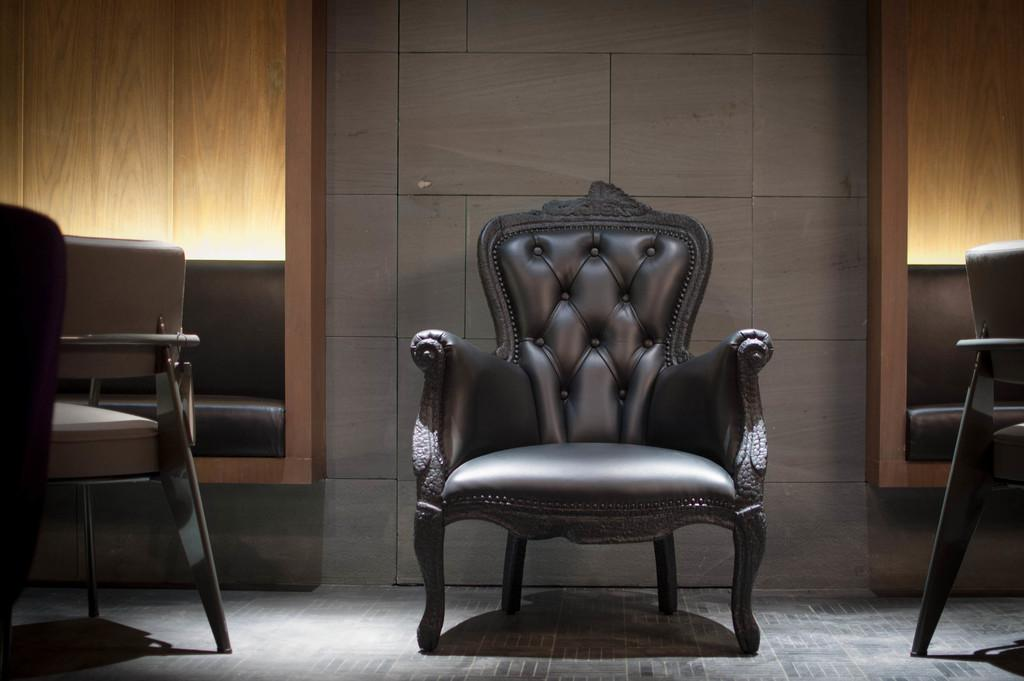What is the main object in the middle of the image? There is a black color chair in the middle of the image. Are there any other chairs visible in the image? Yes, there are chairs on both the right and left sides of the image. What can be seen in the background of the image? There is a wooden wall in the background of the image. What type of milk is being served in the garden in the image? There is no garden or milk present in the image; it features chairs and a wooden wall. 